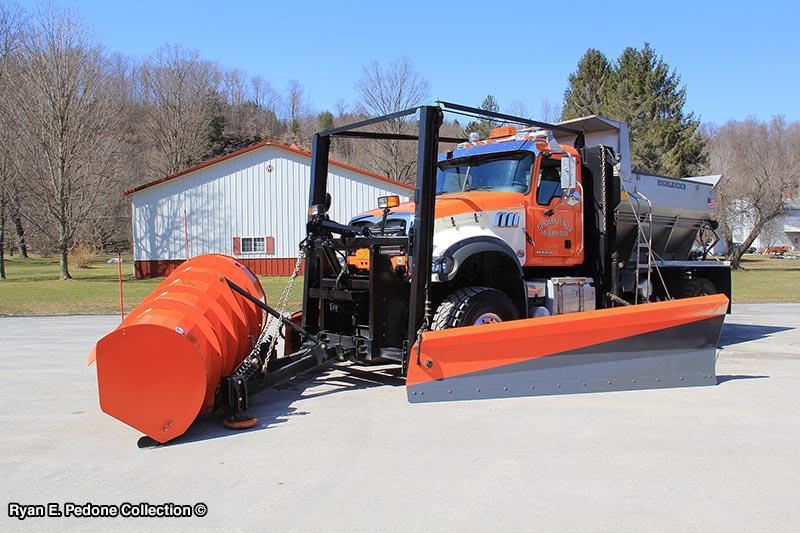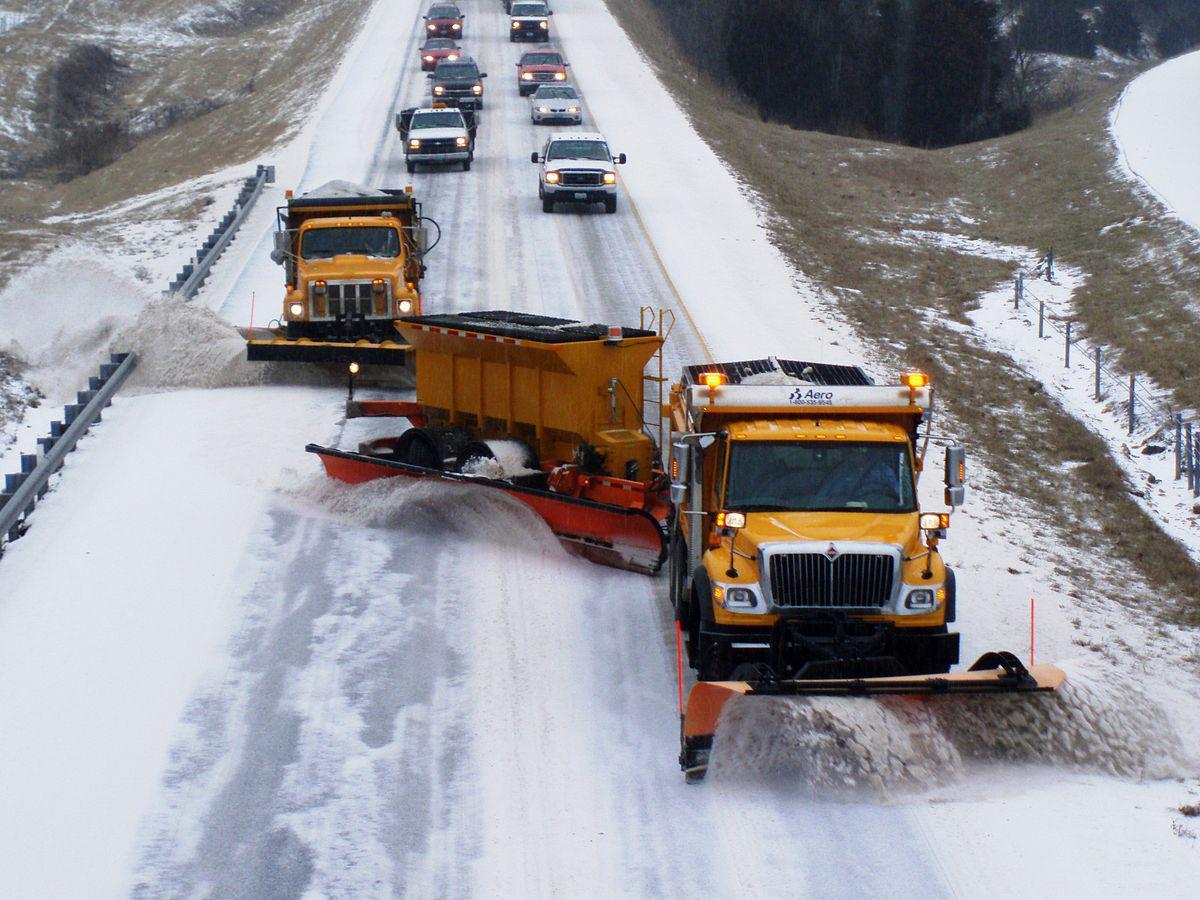The first image is the image on the left, the second image is the image on the right. Given the left and right images, does the statement "In one image, at least one yellow truck with snow blade is on a snowy road, while a second image shows snow removal equipment on clear pavement." hold true? Answer yes or no. Yes. The first image is the image on the left, the second image is the image on the right. For the images shown, is this caption "Snow is visible along the roadside in one of the images featuring a snow plow truck." true? Answer yes or no. Yes. 